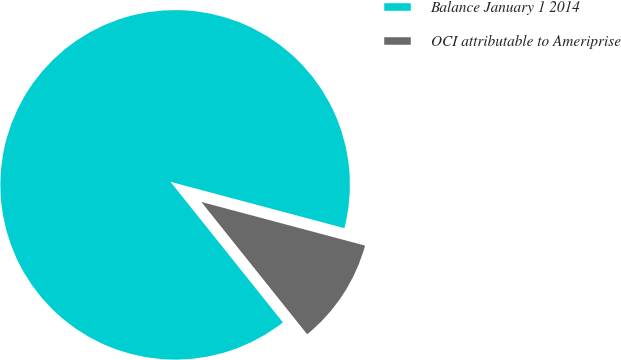Convert chart. <chart><loc_0><loc_0><loc_500><loc_500><pie_chart><fcel>Balance January 1 2014<fcel>OCI attributable to Ameriprise<nl><fcel>89.88%<fcel>10.12%<nl></chart> 